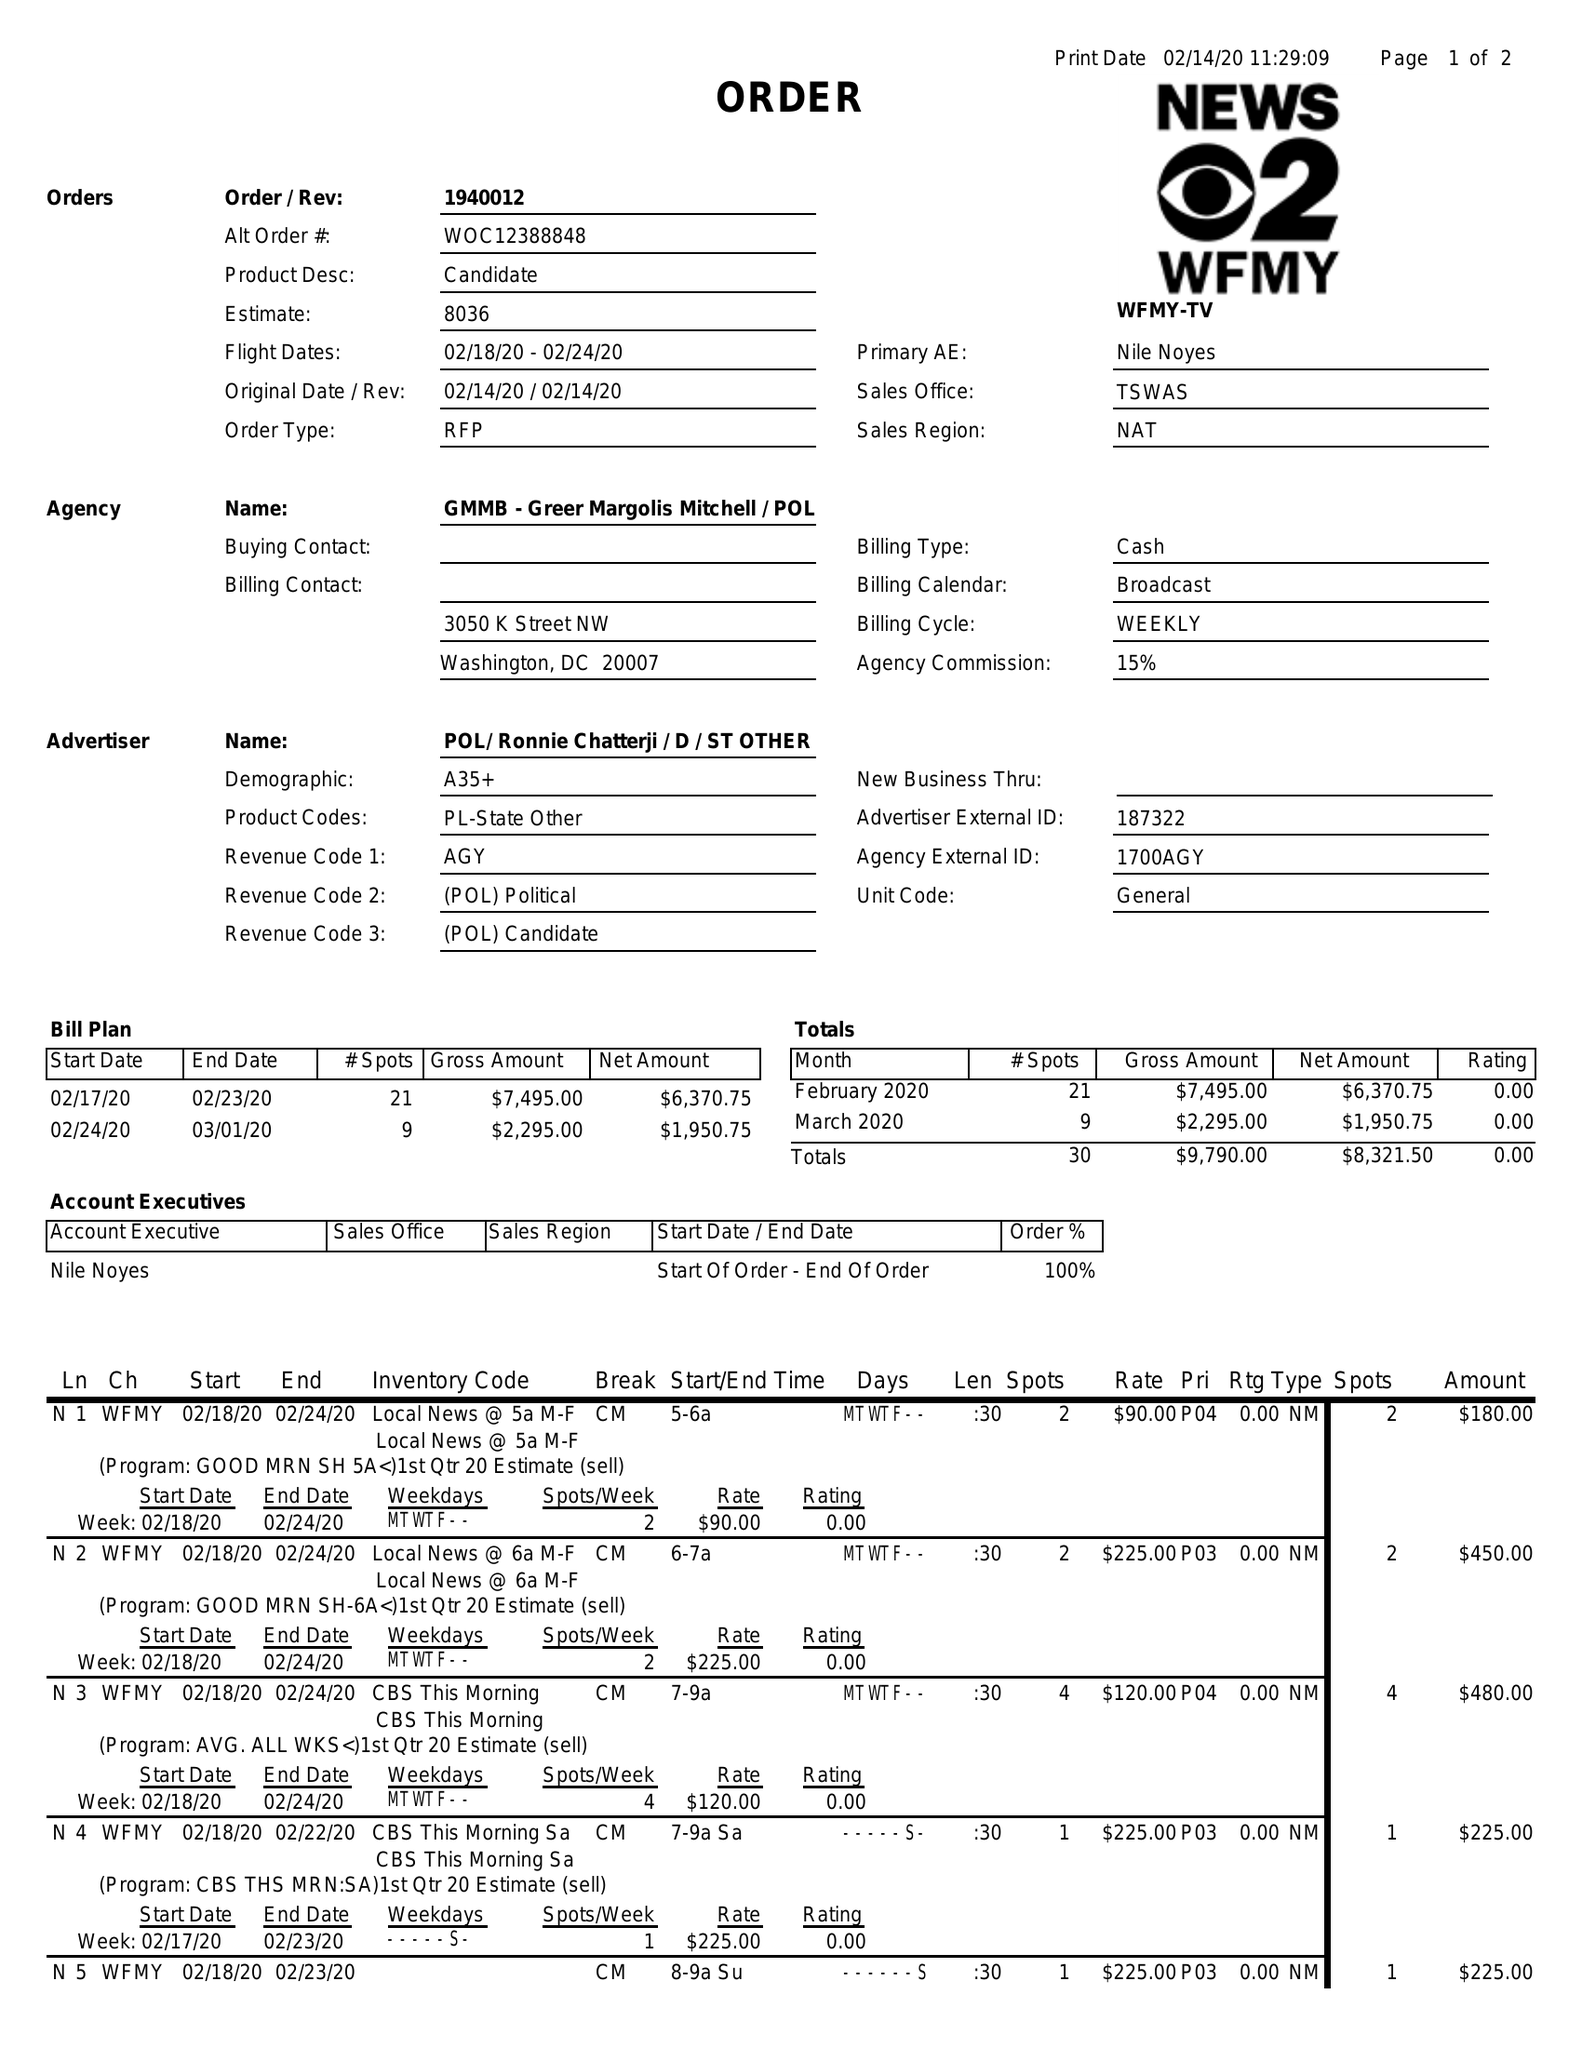What is the value for the contract_num?
Answer the question using a single word or phrase. 1940012 